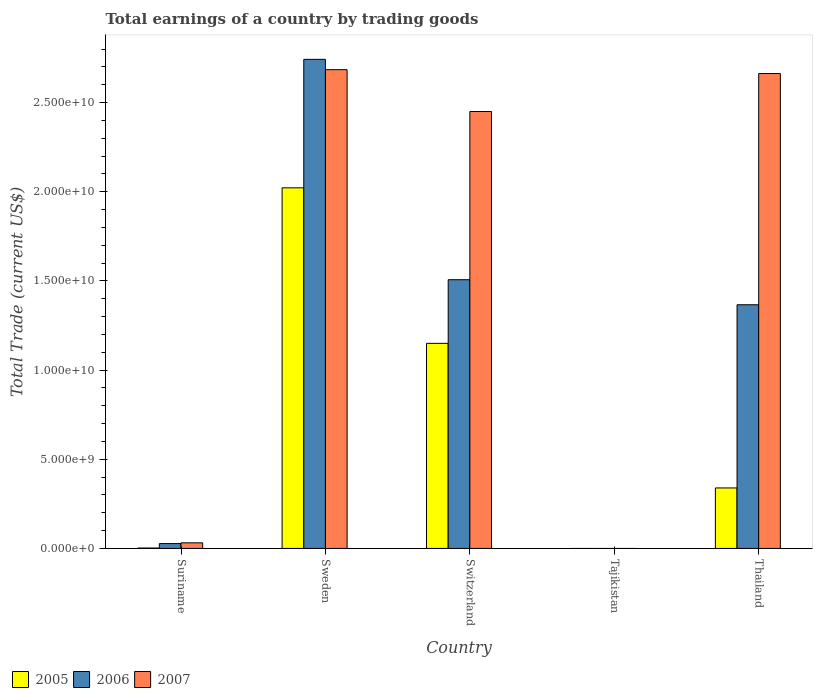How many different coloured bars are there?
Provide a succinct answer. 3. Are the number of bars per tick equal to the number of legend labels?
Offer a very short reply. No. Are the number of bars on each tick of the X-axis equal?
Provide a succinct answer. No. What is the label of the 4th group of bars from the left?
Provide a short and direct response. Tajikistan. What is the total earnings in 2007 in Suriname?
Provide a succinct answer. 3.14e+08. Across all countries, what is the maximum total earnings in 2006?
Your answer should be very brief. 2.74e+1. In which country was the total earnings in 2005 maximum?
Your answer should be compact. Sweden. What is the total total earnings in 2005 in the graph?
Keep it short and to the point. 3.51e+1. What is the difference between the total earnings in 2006 in Suriname and that in Sweden?
Your answer should be very brief. -2.72e+1. What is the difference between the total earnings in 2007 in Switzerland and the total earnings in 2006 in Tajikistan?
Ensure brevity in your answer.  2.45e+1. What is the average total earnings in 2007 per country?
Ensure brevity in your answer.  1.57e+1. What is the difference between the total earnings of/in 2007 and total earnings of/in 2006 in Thailand?
Your response must be concise. 1.30e+1. What is the ratio of the total earnings in 2005 in Suriname to that in Thailand?
Your answer should be compact. 0.01. Is the total earnings in 2007 in Suriname less than that in Thailand?
Keep it short and to the point. Yes. What is the difference between the highest and the second highest total earnings in 2007?
Give a very brief answer. -2.16e+08. What is the difference between the highest and the lowest total earnings in 2005?
Your response must be concise. 2.02e+1. Is the sum of the total earnings in 2007 in Suriname and Sweden greater than the maximum total earnings in 2006 across all countries?
Make the answer very short. No. How many bars are there?
Provide a succinct answer. 12. Are all the bars in the graph horizontal?
Ensure brevity in your answer.  No. What is the difference between two consecutive major ticks on the Y-axis?
Provide a short and direct response. 5.00e+09. Are the values on the major ticks of Y-axis written in scientific E-notation?
Your answer should be very brief. Yes. Does the graph contain any zero values?
Keep it short and to the point. Yes. How are the legend labels stacked?
Your answer should be compact. Horizontal. What is the title of the graph?
Keep it short and to the point. Total earnings of a country by trading goods. Does "2004" appear as one of the legend labels in the graph?
Your answer should be compact. No. What is the label or title of the X-axis?
Offer a very short reply. Country. What is the label or title of the Y-axis?
Your response must be concise. Total Trade (current US$). What is the Total Trade (current US$) of 2005 in Suriname?
Ensure brevity in your answer.  2.24e+07. What is the Total Trade (current US$) of 2006 in Suriname?
Give a very brief answer. 2.72e+08. What is the Total Trade (current US$) in 2007 in Suriname?
Offer a very short reply. 3.14e+08. What is the Total Trade (current US$) in 2005 in Sweden?
Give a very brief answer. 2.02e+1. What is the Total Trade (current US$) in 2006 in Sweden?
Offer a very short reply. 2.74e+1. What is the Total Trade (current US$) in 2007 in Sweden?
Your response must be concise. 2.68e+1. What is the Total Trade (current US$) of 2005 in Switzerland?
Give a very brief answer. 1.15e+1. What is the Total Trade (current US$) in 2006 in Switzerland?
Make the answer very short. 1.51e+1. What is the Total Trade (current US$) of 2007 in Switzerland?
Offer a very short reply. 2.45e+1. What is the Total Trade (current US$) in 2005 in Tajikistan?
Your answer should be compact. 0. What is the Total Trade (current US$) in 2007 in Tajikistan?
Provide a short and direct response. 0. What is the Total Trade (current US$) in 2005 in Thailand?
Provide a short and direct response. 3.39e+09. What is the Total Trade (current US$) of 2006 in Thailand?
Offer a very short reply. 1.37e+1. What is the Total Trade (current US$) of 2007 in Thailand?
Keep it short and to the point. 2.66e+1. Across all countries, what is the maximum Total Trade (current US$) of 2005?
Give a very brief answer. 2.02e+1. Across all countries, what is the maximum Total Trade (current US$) of 2006?
Make the answer very short. 2.74e+1. Across all countries, what is the maximum Total Trade (current US$) of 2007?
Your answer should be compact. 2.68e+1. Across all countries, what is the minimum Total Trade (current US$) of 2005?
Ensure brevity in your answer.  0. Across all countries, what is the minimum Total Trade (current US$) of 2006?
Your answer should be very brief. 0. What is the total Total Trade (current US$) of 2005 in the graph?
Your response must be concise. 3.51e+1. What is the total Total Trade (current US$) of 2006 in the graph?
Provide a short and direct response. 5.64e+1. What is the total Total Trade (current US$) of 2007 in the graph?
Keep it short and to the point. 7.83e+1. What is the difference between the Total Trade (current US$) in 2005 in Suriname and that in Sweden?
Offer a very short reply. -2.02e+1. What is the difference between the Total Trade (current US$) of 2006 in Suriname and that in Sweden?
Offer a very short reply. -2.72e+1. What is the difference between the Total Trade (current US$) of 2007 in Suriname and that in Sweden?
Offer a terse response. -2.65e+1. What is the difference between the Total Trade (current US$) in 2005 in Suriname and that in Switzerland?
Make the answer very short. -1.15e+1. What is the difference between the Total Trade (current US$) of 2006 in Suriname and that in Switzerland?
Provide a short and direct response. -1.48e+1. What is the difference between the Total Trade (current US$) of 2007 in Suriname and that in Switzerland?
Keep it short and to the point. -2.42e+1. What is the difference between the Total Trade (current US$) in 2005 in Suriname and that in Thailand?
Make the answer very short. -3.37e+09. What is the difference between the Total Trade (current US$) of 2006 in Suriname and that in Thailand?
Provide a succinct answer. -1.34e+1. What is the difference between the Total Trade (current US$) of 2007 in Suriname and that in Thailand?
Offer a very short reply. -2.63e+1. What is the difference between the Total Trade (current US$) in 2005 in Sweden and that in Switzerland?
Provide a short and direct response. 8.72e+09. What is the difference between the Total Trade (current US$) in 2006 in Sweden and that in Switzerland?
Offer a very short reply. 1.24e+1. What is the difference between the Total Trade (current US$) in 2007 in Sweden and that in Switzerland?
Provide a succinct answer. 2.35e+09. What is the difference between the Total Trade (current US$) in 2005 in Sweden and that in Thailand?
Provide a short and direct response. 1.68e+1. What is the difference between the Total Trade (current US$) of 2006 in Sweden and that in Thailand?
Your response must be concise. 1.38e+1. What is the difference between the Total Trade (current US$) in 2007 in Sweden and that in Thailand?
Provide a short and direct response. 2.16e+08. What is the difference between the Total Trade (current US$) in 2005 in Switzerland and that in Thailand?
Your response must be concise. 8.11e+09. What is the difference between the Total Trade (current US$) of 2006 in Switzerland and that in Thailand?
Your response must be concise. 1.40e+09. What is the difference between the Total Trade (current US$) in 2007 in Switzerland and that in Thailand?
Provide a short and direct response. -2.13e+09. What is the difference between the Total Trade (current US$) of 2005 in Suriname and the Total Trade (current US$) of 2006 in Sweden?
Offer a terse response. -2.74e+1. What is the difference between the Total Trade (current US$) in 2005 in Suriname and the Total Trade (current US$) in 2007 in Sweden?
Your response must be concise. -2.68e+1. What is the difference between the Total Trade (current US$) in 2006 in Suriname and the Total Trade (current US$) in 2007 in Sweden?
Give a very brief answer. -2.66e+1. What is the difference between the Total Trade (current US$) of 2005 in Suriname and the Total Trade (current US$) of 2006 in Switzerland?
Provide a succinct answer. -1.50e+1. What is the difference between the Total Trade (current US$) in 2005 in Suriname and the Total Trade (current US$) in 2007 in Switzerland?
Ensure brevity in your answer.  -2.45e+1. What is the difference between the Total Trade (current US$) in 2006 in Suriname and the Total Trade (current US$) in 2007 in Switzerland?
Offer a very short reply. -2.42e+1. What is the difference between the Total Trade (current US$) of 2005 in Suriname and the Total Trade (current US$) of 2006 in Thailand?
Your answer should be very brief. -1.36e+1. What is the difference between the Total Trade (current US$) in 2005 in Suriname and the Total Trade (current US$) in 2007 in Thailand?
Your answer should be compact. -2.66e+1. What is the difference between the Total Trade (current US$) in 2006 in Suriname and the Total Trade (current US$) in 2007 in Thailand?
Provide a succinct answer. -2.64e+1. What is the difference between the Total Trade (current US$) of 2005 in Sweden and the Total Trade (current US$) of 2006 in Switzerland?
Your answer should be compact. 5.15e+09. What is the difference between the Total Trade (current US$) in 2005 in Sweden and the Total Trade (current US$) in 2007 in Switzerland?
Offer a terse response. -4.28e+09. What is the difference between the Total Trade (current US$) of 2006 in Sweden and the Total Trade (current US$) of 2007 in Switzerland?
Keep it short and to the point. 2.93e+09. What is the difference between the Total Trade (current US$) in 2005 in Sweden and the Total Trade (current US$) in 2006 in Thailand?
Offer a terse response. 6.56e+09. What is the difference between the Total Trade (current US$) of 2005 in Sweden and the Total Trade (current US$) of 2007 in Thailand?
Your answer should be compact. -6.41e+09. What is the difference between the Total Trade (current US$) in 2006 in Sweden and the Total Trade (current US$) in 2007 in Thailand?
Provide a succinct answer. 7.96e+08. What is the difference between the Total Trade (current US$) in 2005 in Switzerland and the Total Trade (current US$) in 2006 in Thailand?
Your answer should be very brief. -2.16e+09. What is the difference between the Total Trade (current US$) of 2005 in Switzerland and the Total Trade (current US$) of 2007 in Thailand?
Your answer should be compact. -1.51e+1. What is the difference between the Total Trade (current US$) in 2006 in Switzerland and the Total Trade (current US$) in 2007 in Thailand?
Make the answer very short. -1.16e+1. What is the average Total Trade (current US$) in 2005 per country?
Provide a short and direct response. 7.03e+09. What is the average Total Trade (current US$) of 2006 per country?
Your answer should be very brief. 1.13e+1. What is the average Total Trade (current US$) of 2007 per country?
Keep it short and to the point. 1.57e+1. What is the difference between the Total Trade (current US$) in 2005 and Total Trade (current US$) in 2006 in Suriname?
Provide a succinct answer. -2.50e+08. What is the difference between the Total Trade (current US$) in 2005 and Total Trade (current US$) in 2007 in Suriname?
Provide a short and direct response. -2.92e+08. What is the difference between the Total Trade (current US$) of 2006 and Total Trade (current US$) of 2007 in Suriname?
Ensure brevity in your answer.  -4.23e+07. What is the difference between the Total Trade (current US$) in 2005 and Total Trade (current US$) in 2006 in Sweden?
Give a very brief answer. -7.21e+09. What is the difference between the Total Trade (current US$) of 2005 and Total Trade (current US$) of 2007 in Sweden?
Provide a short and direct response. -6.63e+09. What is the difference between the Total Trade (current US$) of 2006 and Total Trade (current US$) of 2007 in Sweden?
Your response must be concise. 5.80e+08. What is the difference between the Total Trade (current US$) of 2005 and Total Trade (current US$) of 2006 in Switzerland?
Your answer should be very brief. -3.57e+09. What is the difference between the Total Trade (current US$) of 2005 and Total Trade (current US$) of 2007 in Switzerland?
Keep it short and to the point. -1.30e+1. What is the difference between the Total Trade (current US$) in 2006 and Total Trade (current US$) in 2007 in Switzerland?
Provide a short and direct response. -9.43e+09. What is the difference between the Total Trade (current US$) of 2005 and Total Trade (current US$) of 2006 in Thailand?
Keep it short and to the point. -1.03e+1. What is the difference between the Total Trade (current US$) in 2005 and Total Trade (current US$) in 2007 in Thailand?
Your answer should be very brief. -2.32e+1. What is the difference between the Total Trade (current US$) in 2006 and Total Trade (current US$) in 2007 in Thailand?
Ensure brevity in your answer.  -1.30e+1. What is the ratio of the Total Trade (current US$) of 2005 in Suriname to that in Sweden?
Your answer should be compact. 0. What is the ratio of the Total Trade (current US$) of 2006 in Suriname to that in Sweden?
Provide a short and direct response. 0.01. What is the ratio of the Total Trade (current US$) in 2007 in Suriname to that in Sweden?
Your response must be concise. 0.01. What is the ratio of the Total Trade (current US$) in 2005 in Suriname to that in Switzerland?
Your response must be concise. 0. What is the ratio of the Total Trade (current US$) of 2006 in Suriname to that in Switzerland?
Ensure brevity in your answer.  0.02. What is the ratio of the Total Trade (current US$) in 2007 in Suriname to that in Switzerland?
Make the answer very short. 0.01. What is the ratio of the Total Trade (current US$) in 2005 in Suriname to that in Thailand?
Provide a succinct answer. 0.01. What is the ratio of the Total Trade (current US$) in 2006 in Suriname to that in Thailand?
Ensure brevity in your answer.  0.02. What is the ratio of the Total Trade (current US$) in 2007 in Suriname to that in Thailand?
Your answer should be compact. 0.01. What is the ratio of the Total Trade (current US$) of 2005 in Sweden to that in Switzerland?
Provide a short and direct response. 1.76. What is the ratio of the Total Trade (current US$) in 2006 in Sweden to that in Switzerland?
Offer a very short reply. 1.82. What is the ratio of the Total Trade (current US$) in 2007 in Sweden to that in Switzerland?
Offer a terse response. 1.1. What is the ratio of the Total Trade (current US$) of 2005 in Sweden to that in Thailand?
Keep it short and to the point. 5.96. What is the ratio of the Total Trade (current US$) in 2006 in Sweden to that in Thailand?
Ensure brevity in your answer.  2.01. What is the ratio of the Total Trade (current US$) of 2007 in Sweden to that in Thailand?
Your response must be concise. 1.01. What is the ratio of the Total Trade (current US$) in 2005 in Switzerland to that in Thailand?
Offer a very short reply. 3.39. What is the ratio of the Total Trade (current US$) of 2006 in Switzerland to that in Thailand?
Give a very brief answer. 1.1. What is the difference between the highest and the second highest Total Trade (current US$) of 2005?
Offer a very short reply. 8.72e+09. What is the difference between the highest and the second highest Total Trade (current US$) in 2006?
Keep it short and to the point. 1.24e+1. What is the difference between the highest and the second highest Total Trade (current US$) in 2007?
Your answer should be compact. 2.16e+08. What is the difference between the highest and the lowest Total Trade (current US$) in 2005?
Make the answer very short. 2.02e+1. What is the difference between the highest and the lowest Total Trade (current US$) in 2006?
Provide a succinct answer. 2.74e+1. What is the difference between the highest and the lowest Total Trade (current US$) of 2007?
Offer a very short reply. 2.68e+1. 